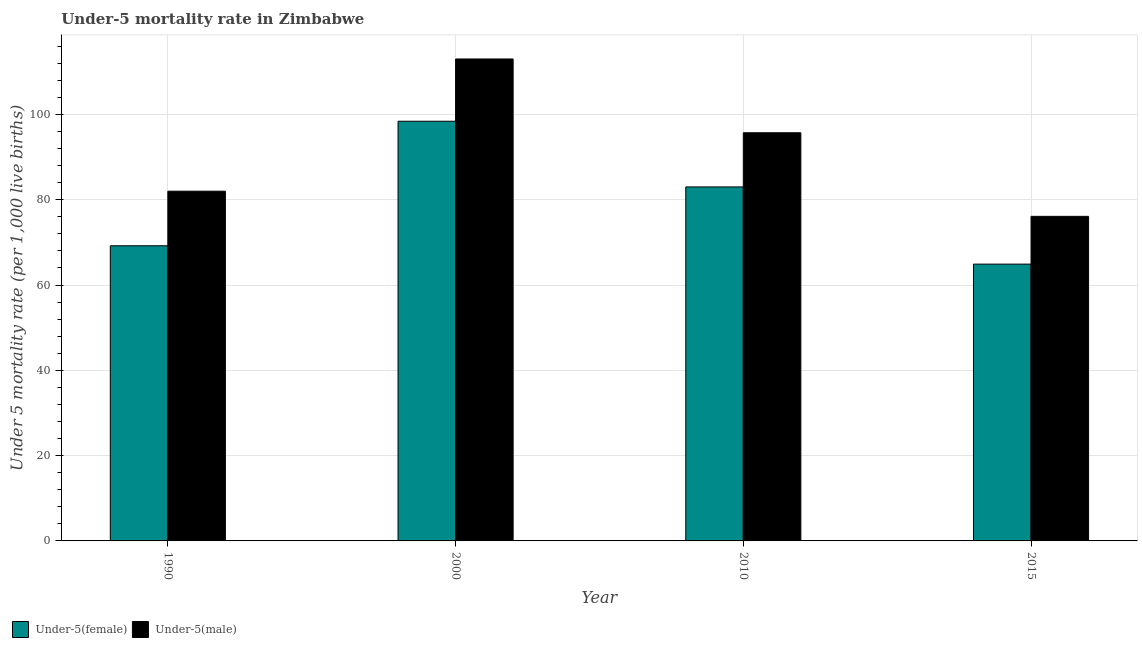How many different coloured bars are there?
Ensure brevity in your answer.  2. Are the number of bars per tick equal to the number of legend labels?
Provide a succinct answer. Yes. How many bars are there on the 2nd tick from the left?
Offer a very short reply. 2. What is the label of the 4th group of bars from the left?
Offer a very short reply. 2015. In how many cases, is the number of bars for a given year not equal to the number of legend labels?
Keep it short and to the point. 0. What is the under-5 female mortality rate in 2015?
Offer a very short reply. 64.9. Across all years, what is the maximum under-5 female mortality rate?
Provide a short and direct response. 98.4. Across all years, what is the minimum under-5 male mortality rate?
Your answer should be very brief. 76.1. In which year was the under-5 female mortality rate maximum?
Your response must be concise. 2000. In which year was the under-5 female mortality rate minimum?
Keep it short and to the point. 2015. What is the total under-5 female mortality rate in the graph?
Your answer should be compact. 315.5. What is the difference between the under-5 female mortality rate in 1990 and that in 2015?
Keep it short and to the point. 4.3. What is the difference between the under-5 male mortality rate in 1990 and the under-5 female mortality rate in 2010?
Offer a very short reply. -13.7. What is the average under-5 male mortality rate per year?
Offer a terse response. 91.7. What is the ratio of the under-5 female mortality rate in 2010 to that in 2015?
Give a very brief answer. 1.28. Is the difference between the under-5 male mortality rate in 1990 and 2000 greater than the difference between the under-5 female mortality rate in 1990 and 2000?
Offer a terse response. No. What is the difference between the highest and the second highest under-5 male mortality rate?
Provide a succinct answer. 17.3. What is the difference between the highest and the lowest under-5 female mortality rate?
Provide a short and direct response. 33.5. Is the sum of the under-5 female mortality rate in 2010 and 2015 greater than the maximum under-5 male mortality rate across all years?
Ensure brevity in your answer.  Yes. What does the 1st bar from the left in 2010 represents?
Your answer should be compact. Under-5(female). What does the 1st bar from the right in 2015 represents?
Provide a succinct answer. Under-5(male). How many bars are there?
Ensure brevity in your answer.  8. How many years are there in the graph?
Offer a terse response. 4. What is the difference between two consecutive major ticks on the Y-axis?
Make the answer very short. 20. Are the values on the major ticks of Y-axis written in scientific E-notation?
Make the answer very short. No. Does the graph contain any zero values?
Your answer should be compact. No. Does the graph contain grids?
Make the answer very short. Yes. How are the legend labels stacked?
Provide a succinct answer. Horizontal. What is the title of the graph?
Ensure brevity in your answer.  Under-5 mortality rate in Zimbabwe. What is the label or title of the X-axis?
Provide a short and direct response. Year. What is the label or title of the Y-axis?
Offer a terse response. Under 5 mortality rate (per 1,0 live births). What is the Under 5 mortality rate (per 1,000 live births) of Under-5(female) in 1990?
Provide a succinct answer. 69.2. What is the Under 5 mortality rate (per 1,000 live births) in Under-5(male) in 1990?
Your answer should be compact. 82. What is the Under 5 mortality rate (per 1,000 live births) in Under-5(female) in 2000?
Provide a short and direct response. 98.4. What is the Under 5 mortality rate (per 1,000 live births) of Under-5(male) in 2000?
Your answer should be compact. 113. What is the Under 5 mortality rate (per 1,000 live births) in Under-5(male) in 2010?
Provide a short and direct response. 95.7. What is the Under 5 mortality rate (per 1,000 live births) in Under-5(female) in 2015?
Provide a succinct answer. 64.9. What is the Under 5 mortality rate (per 1,000 live births) of Under-5(male) in 2015?
Provide a short and direct response. 76.1. Across all years, what is the maximum Under 5 mortality rate (per 1,000 live births) in Under-5(female)?
Your answer should be very brief. 98.4. Across all years, what is the maximum Under 5 mortality rate (per 1,000 live births) of Under-5(male)?
Offer a very short reply. 113. Across all years, what is the minimum Under 5 mortality rate (per 1,000 live births) of Under-5(female)?
Make the answer very short. 64.9. Across all years, what is the minimum Under 5 mortality rate (per 1,000 live births) of Under-5(male)?
Provide a short and direct response. 76.1. What is the total Under 5 mortality rate (per 1,000 live births) of Under-5(female) in the graph?
Keep it short and to the point. 315.5. What is the total Under 5 mortality rate (per 1,000 live births) of Under-5(male) in the graph?
Offer a very short reply. 366.8. What is the difference between the Under 5 mortality rate (per 1,000 live births) in Under-5(female) in 1990 and that in 2000?
Your response must be concise. -29.2. What is the difference between the Under 5 mortality rate (per 1,000 live births) of Under-5(male) in 1990 and that in 2000?
Make the answer very short. -31. What is the difference between the Under 5 mortality rate (per 1,000 live births) in Under-5(male) in 1990 and that in 2010?
Keep it short and to the point. -13.7. What is the difference between the Under 5 mortality rate (per 1,000 live births) of Under-5(male) in 1990 and that in 2015?
Your answer should be compact. 5.9. What is the difference between the Under 5 mortality rate (per 1,000 live births) in Under-5(male) in 2000 and that in 2010?
Ensure brevity in your answer.  17.3. What is the difference between the Under 5 mortality rate (per 1,000 live births) of Under-5(female) in 2000 and that in 2015?
Your response must be concise. 33.5. What is the difference between the Under 5 mortality rate (per 1,000 live births) of Under-5(male) in 2000 and that in 2015?
Your answer should be compact. 36.9. What is the difference between the Under 5 mortality rate (per 1,000 live births) in Under-5(female) in 2010 and that in 2015?
Give a very brief answer. 18.1. What is the difference between the Under 5 mortality rate (per 1,000 live births) of Under-5(male) in 2010 and that in 2015?
Make the answer very short. 19.6. What is the difference between the Under 5 mortality rate (per 1,000 live births) in Under-5(female) in 1990 and the Under 5 mortality rate (per 1,000 live births) in Under-5(male) in 2000?
Make the answer very short. -43.8. What is the difference between the Under 5 mortality rate (per 1,000 live births) of Under-5(female) in 1990 and the Under 5 mortality rate (per 1,000 live births) of Under-5(male) in 2010?
Provide a short and direct response. -26.5. What is the difference between the Under 5 mortality rate (per 1,000 live births) of Under-5(female) in 2000 and the Under 5 mortality rate (per 1,000 live births) of Under-5(male) in 2010?
Your answer should be compact. 2.7. What is the difference between the Under 5 mortality rate (per 1,000 live births) of Under-5(female) in 2000 and the Under 5 mortality rate (per 1,000 live births) of Under-5(male) in 2015?
Provide a short and direct response. 22.3. What is the difference between the Under 5 mortality rate (per 1,000 live births) in Under-5(female) in 2010 and the Under 5 mortality rate (per 1,000 live births) in Under-5(male) in 2015?
Your answer should be compact. 6.9. What is the average Under 5 mortality rate (per 1,000 live births) of Under-5(female) per year?
Your response must be concise. 78.88. What is the average Under 5 mortality rate (per 1,000 live births) in Under-5(male) per year?
Your answer should be very brief. 91.7. In the year 1990, what is the difference between the Under 5 mortality rate (per 1,000 live births) in Under-5(female) and Under 5 mortality rate (per 1,000 live births) in Under-5(male)?
Offer a very short reply. -12.8. In the year 2000, what is the difference between the Under 5 mortality rate (per 1,000 live births) of Under-5(female) and Under 5 mortality rate (per 1,000 live births) of Under-5(male)?
Your response must be concise. -14.6. What is the ratio of the Under 5 mortality rate (per 1,000 live births) of Under-5(female) in 1990 to that in 2000?
Your response must be concise. 0.7. What is the ratio of the Under 5 mortality rate (per 1,000 live births) of Under-5(male) in 1990 to that in 2000?
Ensure brevity in your answer.  0.73. What is the ratio of the Under 5 mortality rate (per 1,000 live births) of Under-5(female) in 1990 to that in 2010?
Make the answer very short. 0.83. What is the ratio of the Under 5 mortality rate (per 1,000 live births) in Under-5(male) in 1990 to that in 2010?
Provide a succinct answer. 0.86. What is the ratio of the Under 5 mortality rate (per 1,000 live births) in Under-5(female) in 1990 to that in 2015?
Make the answer very short. 1.07. What is the ratio of the Under 5 mortality rate (per 1,000 live births) of Under-5(male) in 1990 to that in 2015?
Your answer should be very brief. 1.08. What is the ratio of the Under 5 mortality rate (per 1,000 live births) of Under-5(female) in 2000 to that in 2010?
Your answer should be compact. 1.19. What is the ratio of the Under 5 mortality rate (per 1,000 live births) of Under-5(male) in 2000 to that in 2010?
Give a very brief answer. 1.18. What is the ratio of the Under 5 mortality rate (per 1,000 live births) of Under-5(female) in 2000 to that in 2015?
Give a very brief answer. 1.52. What is the ratio of the Under 5 mortality rate (per 1,000 live births) of Under-5(male) in 2000 to that in 2015?
Keep it short and to the point. 1.48. What is the ratio of the Under 5 mortality rate (per 1,000 live births) in Under-5(female) in 2010 to that in 2015?
Keep it short and to the point. 1.28. What is the ratio of the Under 5 mortality rate (per 1,000 live births) in Under-5(male) in 2010 to that in 2015?
Keep it short and to the point. 1.26. What is the difference between the highest and the second highest Under 5 mortality rate (per 1,000 live births) of Under-5(female)?
Give a very brief answer. 15.4. What is the difference between the highest and the lowest Under 5 mortality rate (per 1,000 live births) in Under-5(female)?
Provide a succinct answer. 33.5. What is the difference between the highest and the lowest Under 5 mortality rate (per 1,000 live births) in Under-5(male)?
Provide a short and direct response. 36.9. 